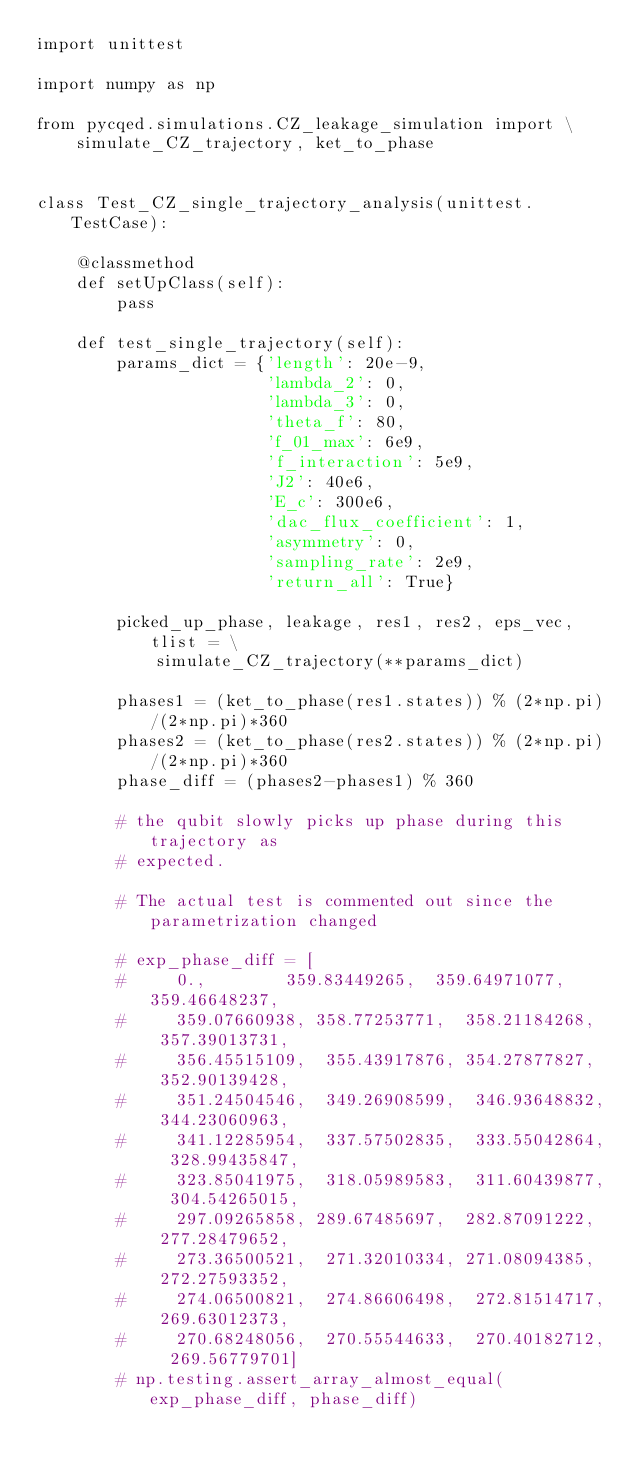<code> <loc_0><loc_0><loc_500><loc_500><_Python_>import unittest

import numpy as np

from pycqed.simulations.CZ_leakage_simulation import \
    simulate_CZ_trajectory, ket_to_phase


class Test_CZ_single_trajectory_analysis(unittest.TestCase):

    @classmethod
    def setUpClass(self):
        pass

    def test_single_trajectory(self):
        params_dict = {'length': 20e-9,
                       'lambda_2': 0,
                       'lambda_3': 0,
                       'theta_f': 80,
                       'f_01_max': 6e9,
                       'f_interaction': 5e9,
                       'J2': 40e6,
                       'E_c': 300e6,
                       'dac_flux_coefficient': 1,
                       'asymmetry': 0,
                       'sampling_rate': 2e9,
                       'return_all': True}

        picked_up_phase, leakage, res1, res2, eps_vec, tlist = \
            simulate_CZ_trajectory(**params_dict)

        phases1 = (ket_to_phase(res1.states)) % (2*np.pi)/(2*np.pi)*360
        phases2 = (ket_to_phase(res2.states)) % (2*np.pi)/(2*np.pi)*360
        phase_diff = (phases2-phases1) % 360

        # the qubit slowly picks up phase during this trajectory as
        # expected.

        # The actual test is commented out since the parametrization changed

        # exp_phase_diff = [
        #     0.,        359.83449265,  359.64971077,  359.46648237,
        #     359.07660938, 358.77253771,  358.21184268,  357.39013731,
        #     356.45515109,  355.43917876, 354.27877827,  352.90139428,
        #     351.24504546,  349.26908599,  346.93648832, 344.23060963,
        #     341.12285954,  337.57502835,  333.55042864,  328.99435847,
        #     323.85041975,  318.05989583,  311.60439877,  304.54265015,
        #     297.09265858, 289.67485697,  282.87091222,  277.28479652,
        #     273.36500521,  271.32010334, 271.08094385,  272.27593352,
        #     274.06500821,  274.86606498,  272.81514717, 269.63012373,
        #     270.68248056,  270.55544633,  270.40182712,  269.56779701]
        # np.testing.assert_array_almost_equal(exp_phase_diff, phase_diff)
</code> 